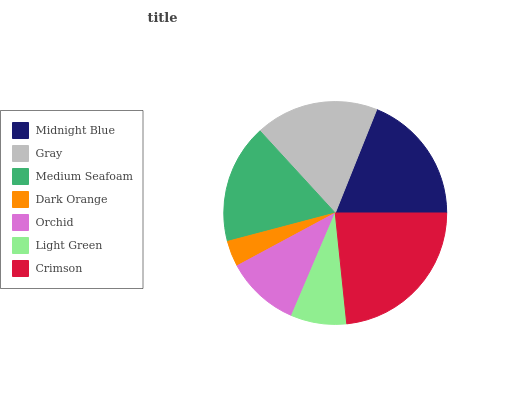Is Dark Orange the minimum?
Answer yes or no. Yes. Is Crimson the maximum?
Answer yes or no. Yes. Is Gray the minimum?
Answer yes or no. No. Is Gray the maximum?
Answer yes or no. No. Is Midnight Blue greater than Gray?
Answer yes or no. Yes. Is Gray less than Midnight Blue?
Answer yes or no. Yes. Is Gray greater than Midnight Blue?
Answer yes or no. No. Is Midnight Blue less than Gray?
Answer yes or no. No. Is Medium Seafoam the high median?
Answer yes or no. Yes. Is Medium Seafoam the low median?
Answer yes or no. Yes. Is Dark Orange the high median?
Answer yes or no. No. Is Light Green the low median?
Answer yes or no. No. 